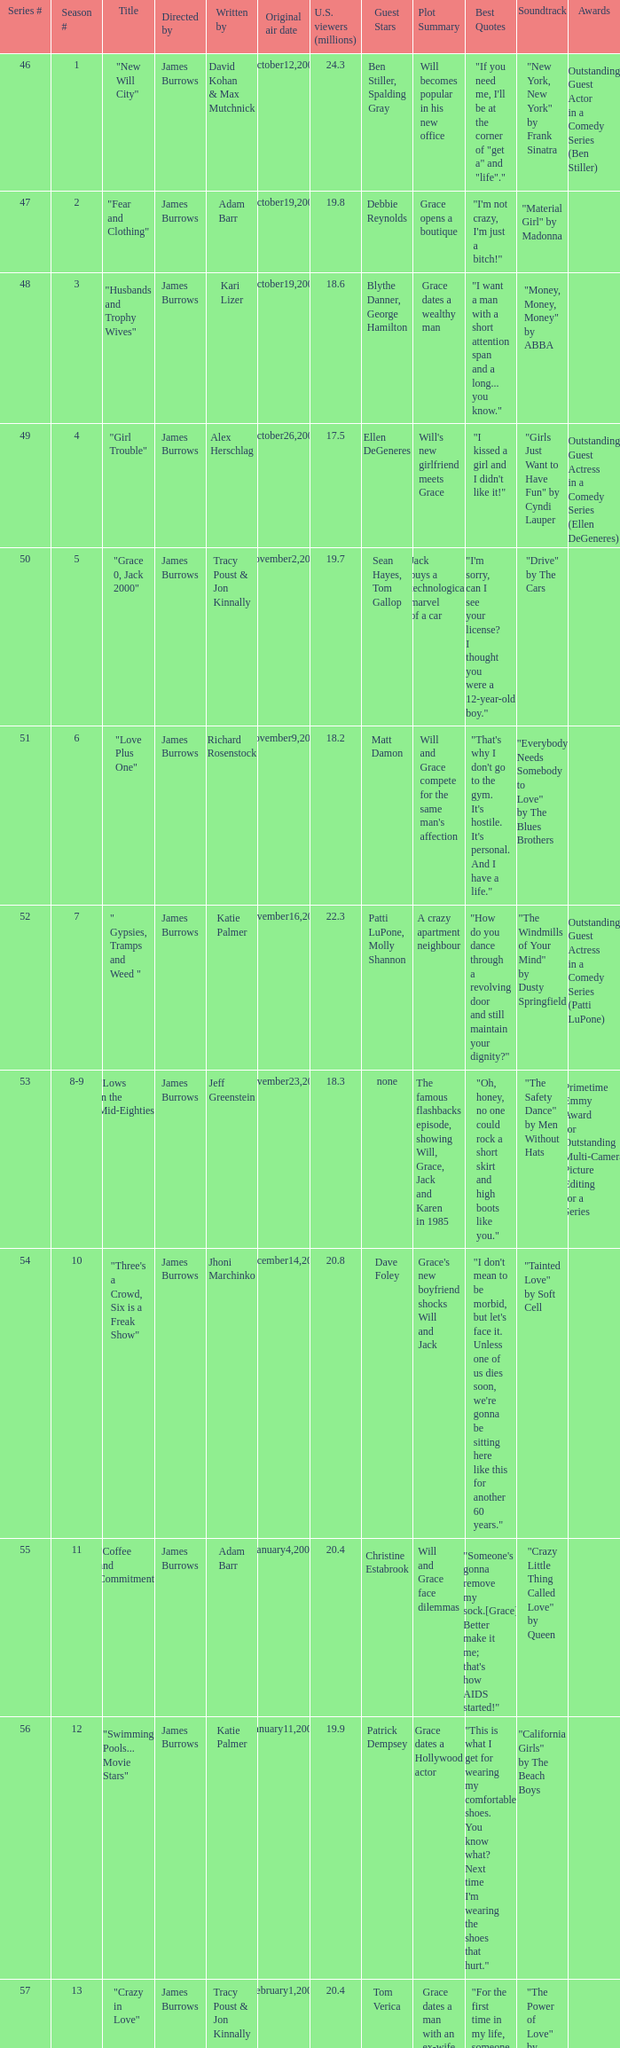Who wrote the episode titled "An Old-fashioned Piano Party"? Jhoni Marchinko, Tracy Poust & Jon Kinnally. 